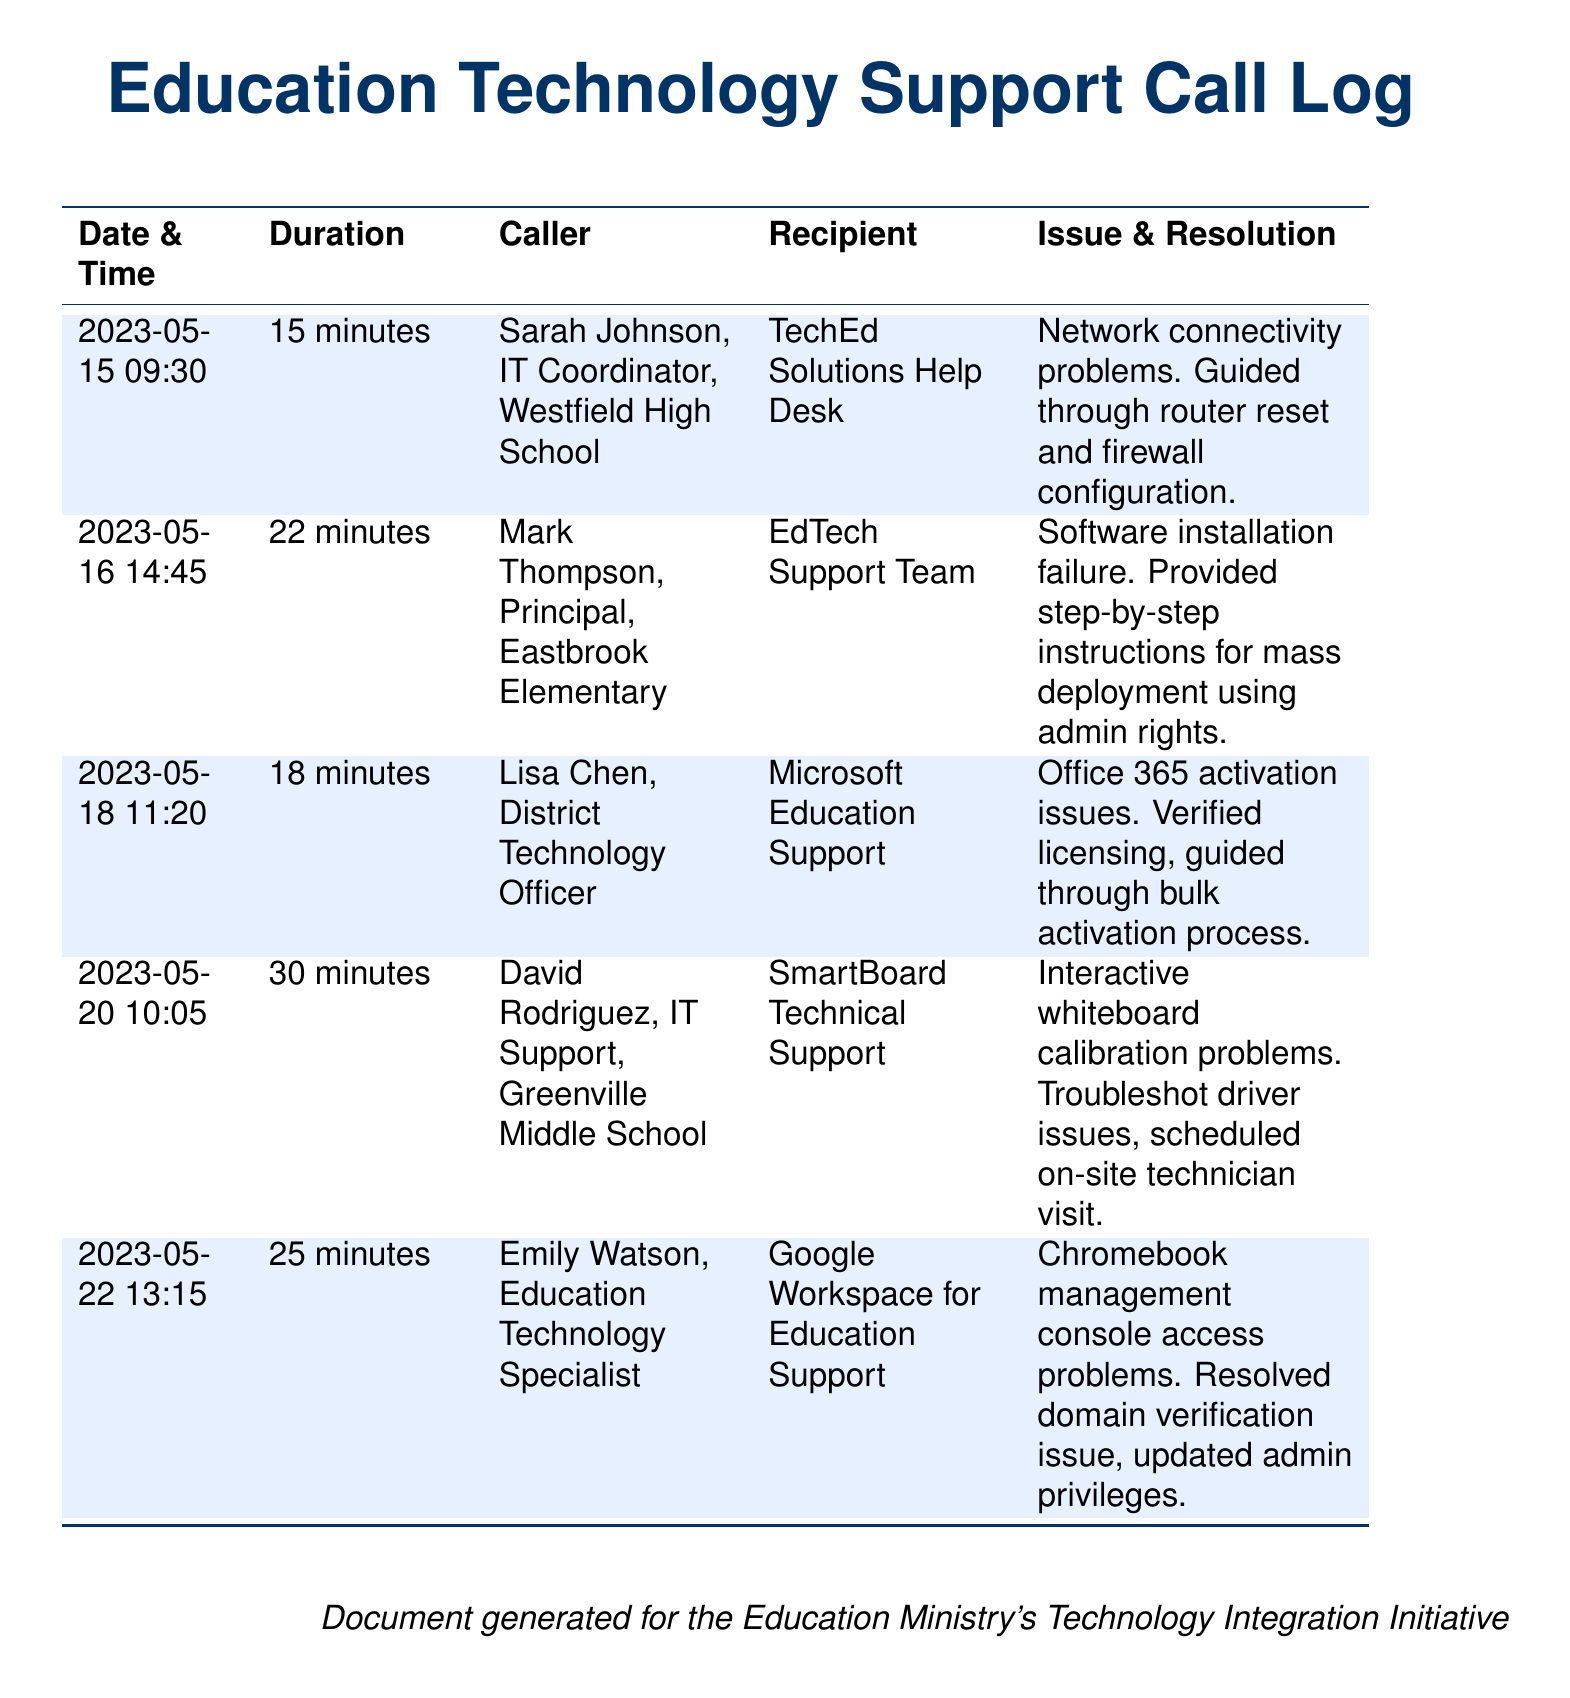What is the date of the first call recorded? The first call in the document is on May 15, 2023.
Answer: May 15, 2023 Who called the TechEd Solutions Help Desk? The caller listed for the TechEd Solutions Help Desk is Sarah Johnson.
Answer: Sarah Johnson What issue was addressed in the call on May 16, 2023? The issue discussed on May 16, 2023, was software installation failure.
Answer: Software installation failure Which school district was involved in the call about Office 365 activation? The caller was the District Technology Officer, indicating involvement from the district.
Answer: District Technology Officer How long was the call with the SmartBoard Technical Support? The duration of the call with SmartBoard Technical Support was 30 minutes.
Answer: 30 minutes What type of support did Emily Watson receive? Emily Watson received support for Google Workspace for Education.
Answer: Google Workspace for Education How many minutes did the call regarding network connectivity problems last? The call lasted for 15 minutes as stated in the log.
Answer: 15 minutes Which technical issue required an on-site technician visit? The issue that required an on-site technician visit was related to interactive whiteboard calibration.
Answer: Interactive whiteboard calibration What was resolved during the Chromebook management console access call? During the Chromebook management console access call, a domain verification issue was resolved.
Answer: Domain verification issue 